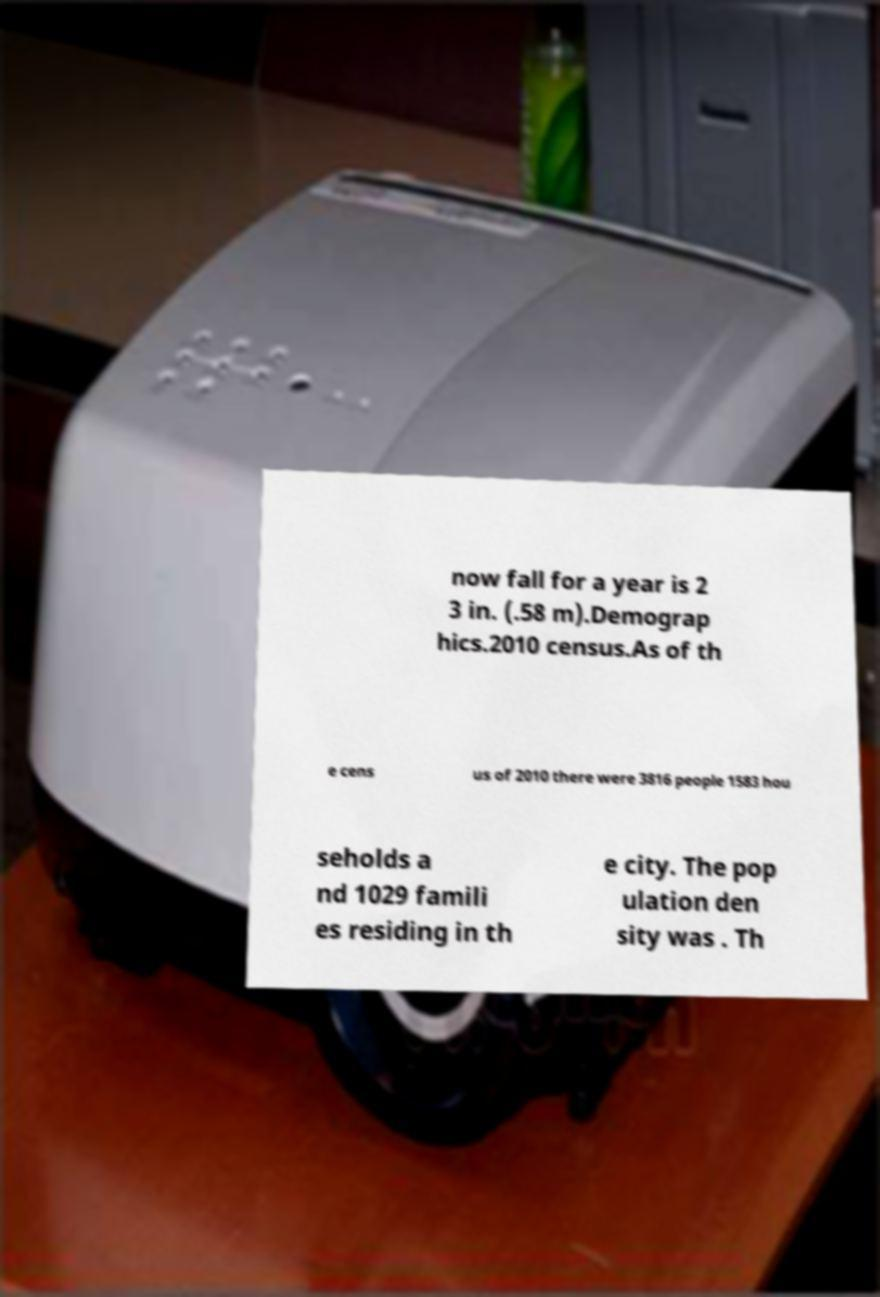What messages or text are displayed in this image? I need them in a readable, typed format. now fall for a year is 2 3 in. (.58 m).Demograp hics.2010 census.As of th e cens us of 2010 there were 3816 people 1583 hou seholds a nd 1029 famili es residing in th e city. The pop ulation den sity was . Th 